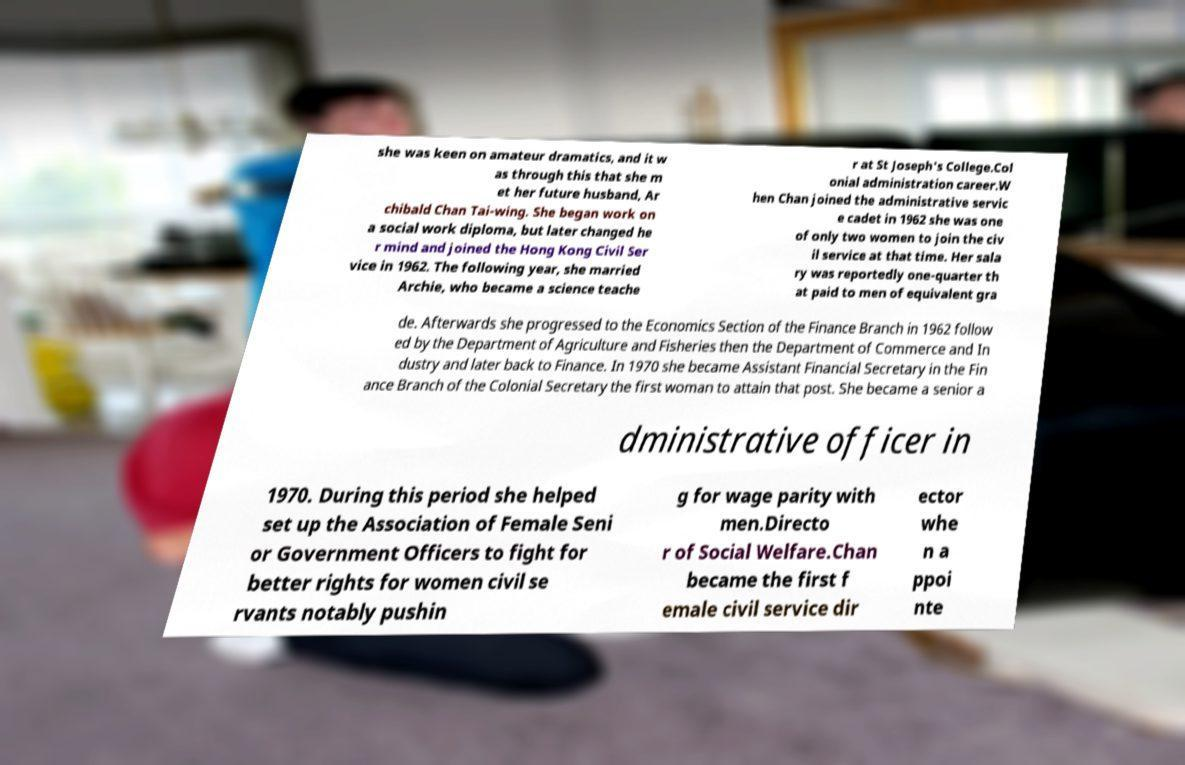Please identify and transcribe the text found in this image. she was keen on amateur dramatics, and it w as through this that she m et her future husband, Ar chibald Chan Tai-wing. She began work on a social work diploma, but later changed he r mind and joined the Hong Kong Civil Ser vice in 1962. The following year, she married Archie, who became a science teache r at St Joseph's College.Col onial administration career.W hen Chan joined the administrative servic e cadet in 1962 she was one of only two women to join the civ il service at that time. Her sala ry was reportedly one-quarter th at paid to men of equivalent gra de. Afterwards she progressed to the Economics Section of the Finance Branch in 1962 follow ed by the Department of Agriculture and Fisheries then the Department of Commerce and In dustry and later back to Finance. In 1970 she became Assistant Financial Secretary in the Fin ance Branch of the Colonial Secretary the first woman to attain that post. She became a senior a dministrative officer in 1970. During this period she helped set up the Association of Female Seni or Government Officers to fight for better rights for women civil se rvants notably pushin g for wage parity with men.Directo r of Social Welfare.Chan became the first f emale civil service dir ector whe n a ppoi nte 